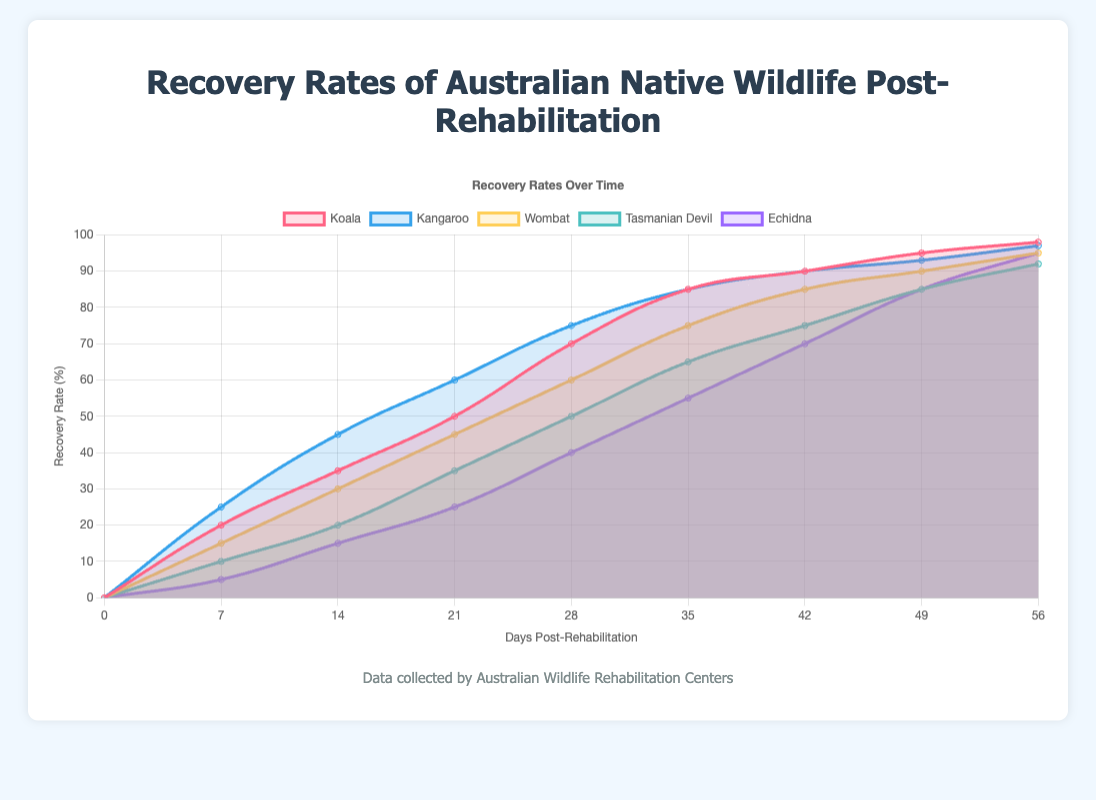What species has the highest recovery rate at 56 days post-rehabilitation? The figure shows the recovery rates of various species at 56 days. By comparing the data points at 56 days, we see which one is the highest.
Answer: Koala Which species has the lowest initial recovery rate? The figure shows the starting recovery rates (day 0) for all species. By comparing these values, we can determine which is the lowest.
Answer: Echidna What is the difference in recovery rates between Koalas and Wombats at 28 days post-rehabilitation? Find the recovery rates for both Koalas (70%) and Wombats (60%) at 28 days from the plot, then subtract the lower rate from the higher one.
Answer: 10% Which species shows the fastest initial recovery rate? To determine the fastest initial recovery, look at the increase in recovery rate from day 0 to day 7 for all species. The species with the highest rate of increase is the fastest.
Answer: Kangaroo How do the recovery rates of Kangaroos and Tasmanian Devils compare at 35 days post-rehabilitation? At 35 days, compare the recovery rates of Kangaroos (85%) and Tasmanian Devils (65%) by checking the data points on the plot.
Answer: Kangaroo has a higher recovery rate by 20% By how much does the recovery rate of the Echidna increase from 14 days to 49 days post-rehabilitation? Find the recovery rates for Echidna at 14 days (15%) and 49 days (85%) and then calculate the difference.
Answer: 70% What is the trend in recovery rates for Koalas from day 0 to day 56? Analyze the plot to see the pattern of the recovery rate for Koalas over time.
Answer: Generally increasing Which species has a recovery rate of approximately 85% at 35 days post-rehabilitation? Identify the species with a recovery rate close to 85% at 35 days by looking at the data points for each species.
Answer: Koala and Kangaroo What is the average recovery rate of Wombats from 21 days to 56 days post-rehabilitation? Calculate the average by adding the recovery rates from 21 days (45%), 28 days (60%), 35 days (75%), 42 days (85%), 49 days (90%), and 56 days (95%), then divide by the number of intervals.
Answer: 75% At which time point do Tasmanian Devils and Echidnas have the same recovery rate? Observe the plot to find the time point where the recovery rates for both Tasmanian Devils and Echidnas intersect.
Answer: 42 days 